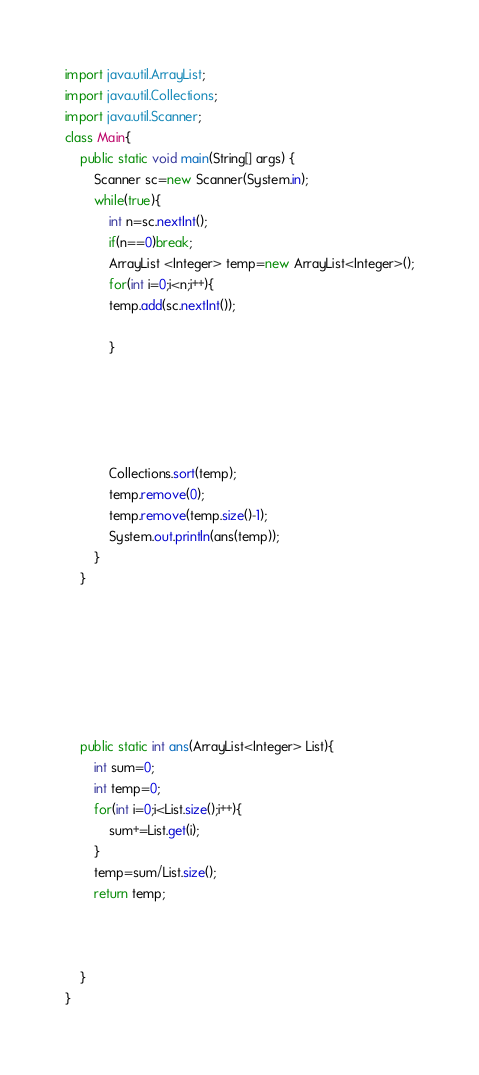<code> <loc_0><loc_0><loc_500><loc_500><_Java_>import java.util.ArrayList;
import java.util.Collections;
import java.util.Scanner;
class Main{
	public static void main(String[] args) {
		Scanner sc=new Scanner(System.in);
		while(true){
			int n=sc.nextInt();
			if(n==0)break;
			ArrayList <Integer> temp=new ArrayList<Integer>();
			for(int i=0;i<n;i++){
			temp.add(sc.nextInt());
			
			}
			
			
			
			
			
			Collections.sort(temp);
			temp.remove(0);
			temp.remove(temp.size()-1);
			System.out.println(ans(temp));
		}
	}
	
	
	
	
	
	
	
	public static int ans(ArrayList<Integer> List){
		int sum=0;
		int temp=0;
		for(int i=0;i<List.size();i++){
			sum+=List.get(i);
		}
		temp=sum/List.size();
		return temp;
		
		
	
	}
}</code> 